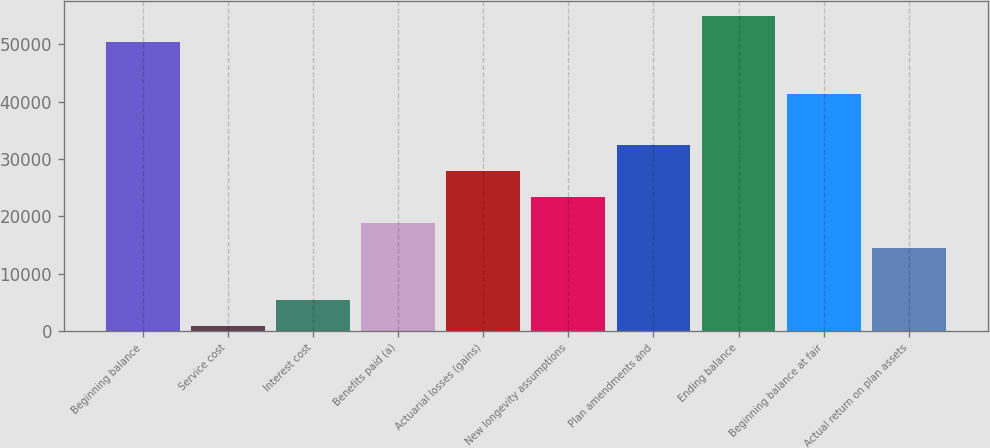<chart> <loc_0><loc_0><loc_500><loc_500><bar_chart><fcel>Beginning balance<fcel>Service cost<fcel>Interest cost<fcel>Benefits paid (a)<fcel>Actuarial losses (gains)<fcel>New longevity assumptions<fcel>Plan amendments and<fcel>Ending balance<fcel>Beginning balance at fair<fcel>Actual return on plan assets<nl><fcel>50379.9<fcel>903<fcel>5400.9<fcel>18894.6<fcel>27890.4<fcel>23392.5<fcel>32388.3<fcel>54877.8<fcel>41384.1<fcel>14396.7<nl></chart> 